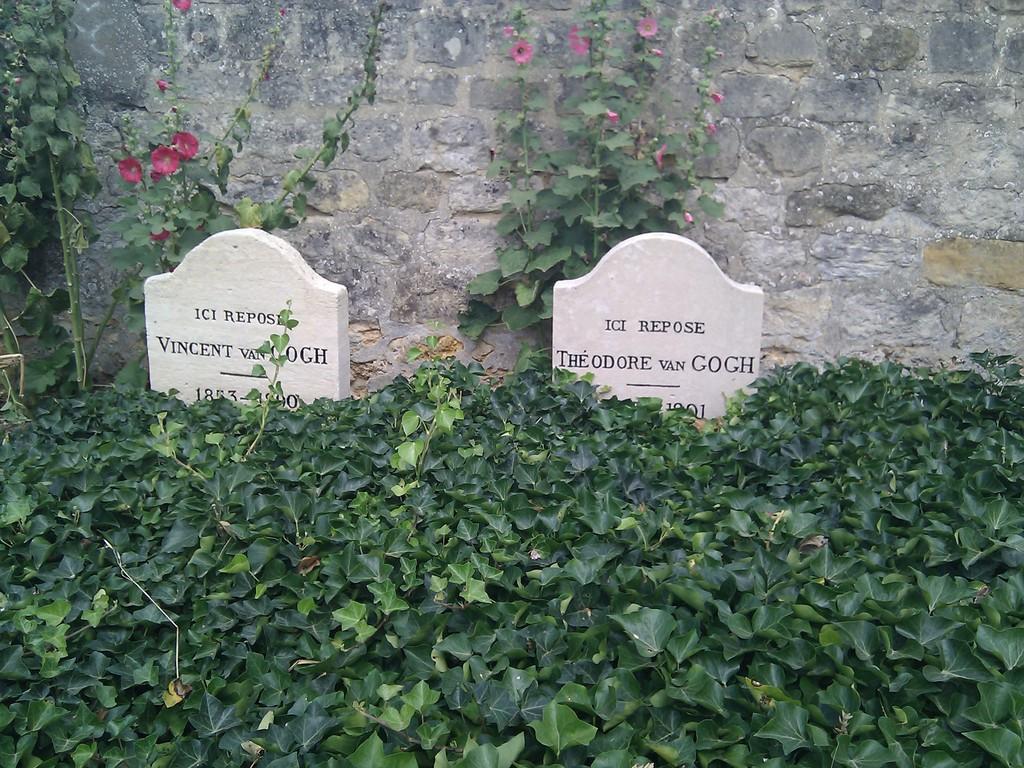Do these two headstones display the same last name?
Provide a short and direct response. Yes. Who is buried on the left?
Your answer should be very brief. Vincent van gogh. 